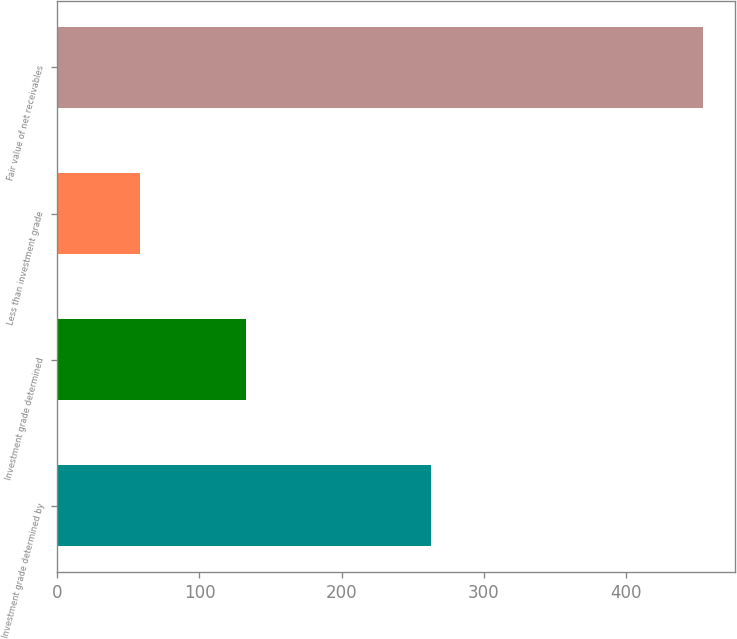Convert chart. <chart><loc_0><loc_0><loc_500><loc_500><bar_chart><fcel>Investment grade determined by<fcel>Investment grade determined<fcel>Less than investment grade<fcel>Fair value of net receivables<nl><fcel>263<fcel>133<fcel>58<fcel>454<nl></chart> 